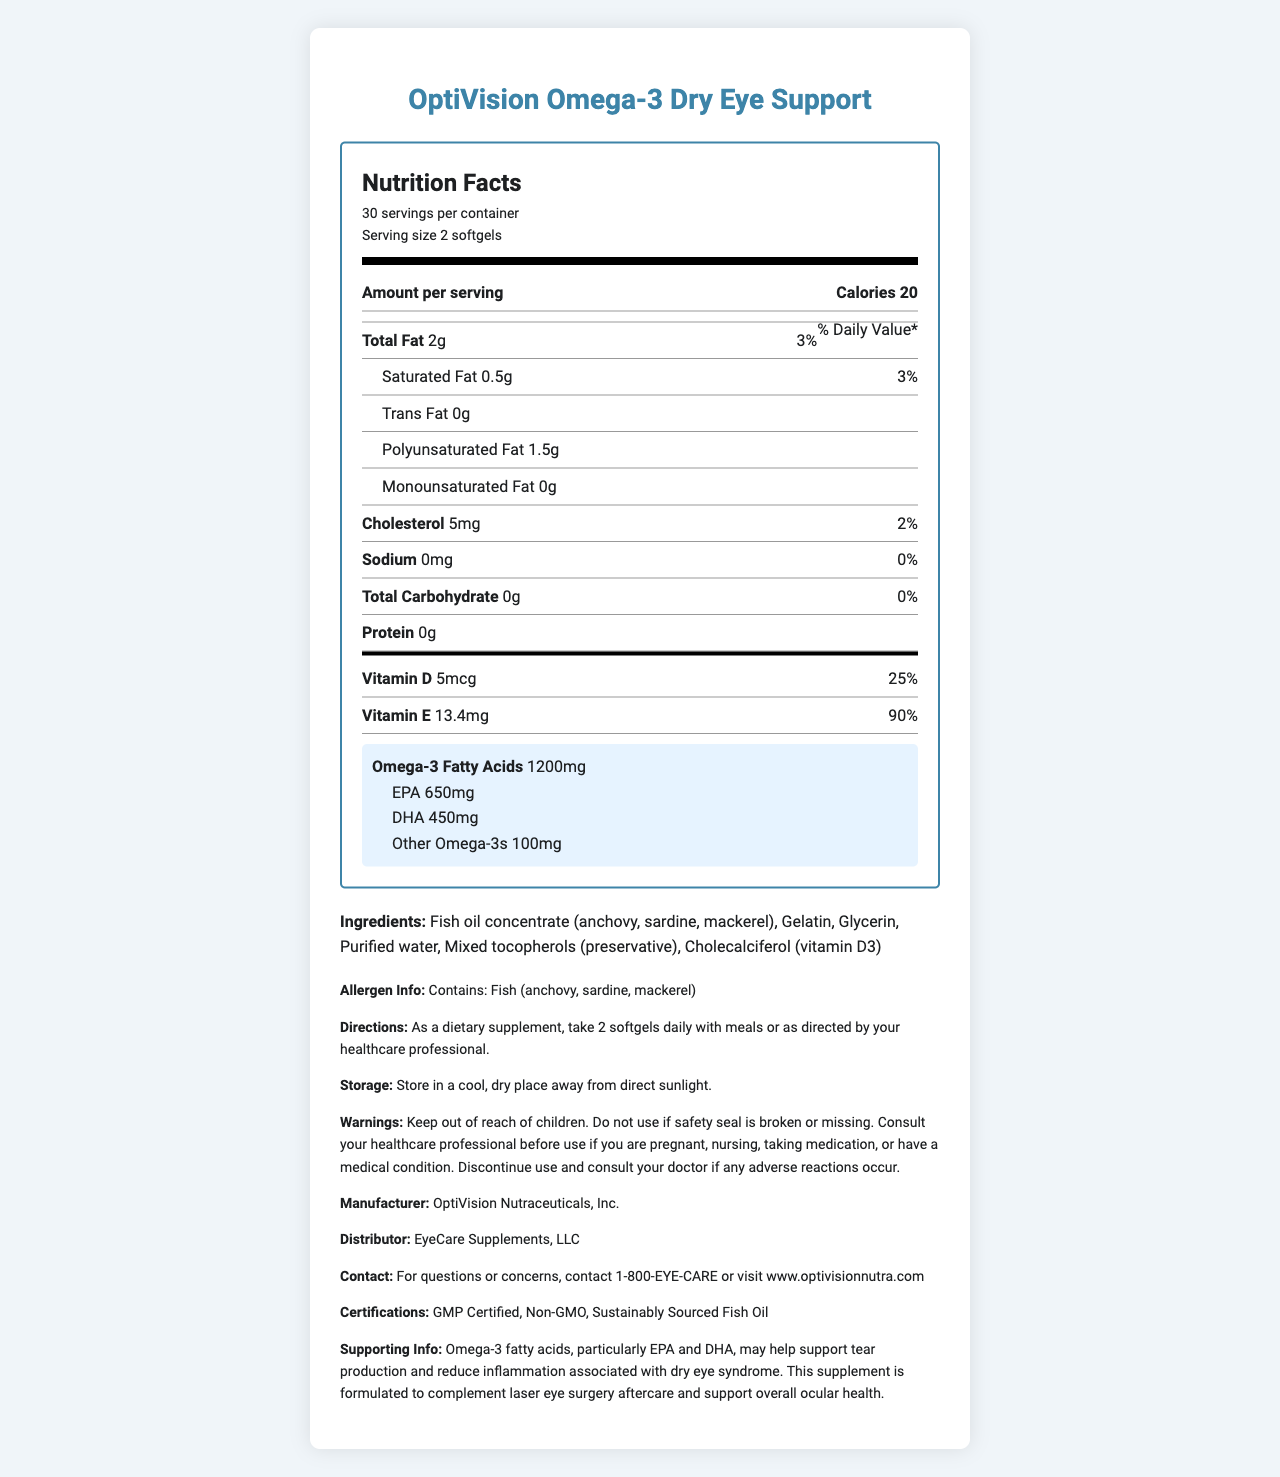what is the serving size for OptiVision Omega-3 Dry Eye Support? The serving size is stated as "2 softgels" in the document.
Answer: 2 softgels how many servings per container does this product provide? The document mentions that there are 30 servings per container.
Answer: 30 servings how much total fat is there per serving and what percentage of the daily value does it represent? The total fat per serving is 2 grams, which represents 3% of the daily value.
Answer: 2g, 3% how much omega-3 fatty acids are there per serving? The document states that each serving contains 1200mg of omega-3 fatty acids.
Answer: 1200mg what are the main types of omega-3 fatty acids included in the supplement and their respective amounts? The main types of omega-3 fatty acids are EPA (650mg), DHA (450mg), and other omega-3s (100mg).
Answer: EPA: 650mg, DHA: 450mg, Other: 100mg what are the ingredients of OptiVision Omega-3 Dry Eye Support? The ingredients are listed in the document.
Answer: Fish oil concentrate (anchovy, sardine, mackerel), Gelatin, Glycerin, Purified water, Mixed tocopherols (preservative), Cholecalciferol (vitamin D3) which vitamin in the supplement has the highest percentage of daily value? Vitamin E has a daily value percentage of 90%, which is the highest among the listed vitamins.
Answer: Vitamin E how many calories are there per serving of this supplement? The document states that each serving contains 20 calories.
Answer: 20 calories what is the recommended daily dosage for this supplement? The document gives the direction to take 2 softgels daily with meals.
Answer: 2 softgels daily with meals or as directed by your healthcare professional what is the total amount of cholesterol per serving and its daily value percentage? The total amount of cholesterol per serving is 5mg, and this represents 2% of the daily value.
Answer: 5mg, 2% what should be avoided during storage of this product? The document specifies to store the product in a cool, dry place away from direct sunlight.
Answer: Direct sunlight which certification ensures the product contains non-genetically modified organisms? A. GMP Certified B. Non-GMO C. Sustainably Sourced Fish Oil The certification "Non-GMO" ensures that the product contains non-genetically modified organisms.
Answer: B. Non-GMO how should this supplement be stored? A. In the fridge B. In a hot place C. In a cool, dry place D. Under direct sunlight The document specifies that the supplement should be stored in a cool, dry place.
Answer: C. In a cool, dry place is this product suitable for individuals allergic to fish? The allergen information indicates that the product contains fish (anchovy, sardine, mackerel), so it is not suitable for individuals allergic to fish.
Answer: No does this product contain any sodium? The document states that the sodium content is 0mg.
Answer: No summarize the key information provided by the nutrition facts label of OptiVision Omega-3 Dry Eye Support. This summary captures the essential facts about the product, including its nutritional content, omega-3 composition, vitamins, ingredients, certifications, and dosage instructions.
Answer: The OptiVision Omega-3 Dry Eye Support supplement provides 20 calories per serving (2 softgels) with 2g of total fat (3% DV). It includes significant amounts of omega-3 fatty acids (1200mg) divided into EPA (650mg), DHA (450mg), and other types (100mg). It features vitamin D (5mcg, 25% DV) and a high amount of vitamin E (13.4mg, 90% DV). The supplement uses fish oil concentrate from anchovy, sardine, and mackerel, and contains gelatin, glycerin, purified water, mixed tocopherols, and cholecalciferol. It is non-GMO, GMP certified, and sustainably sourced. The product is recommended to be taken twice daily with meals. what is the exact amount of purified water used in this supplement? The document specifies purified water as an ingredient but does not provide the exact amount used.
Answer: Not enough information 